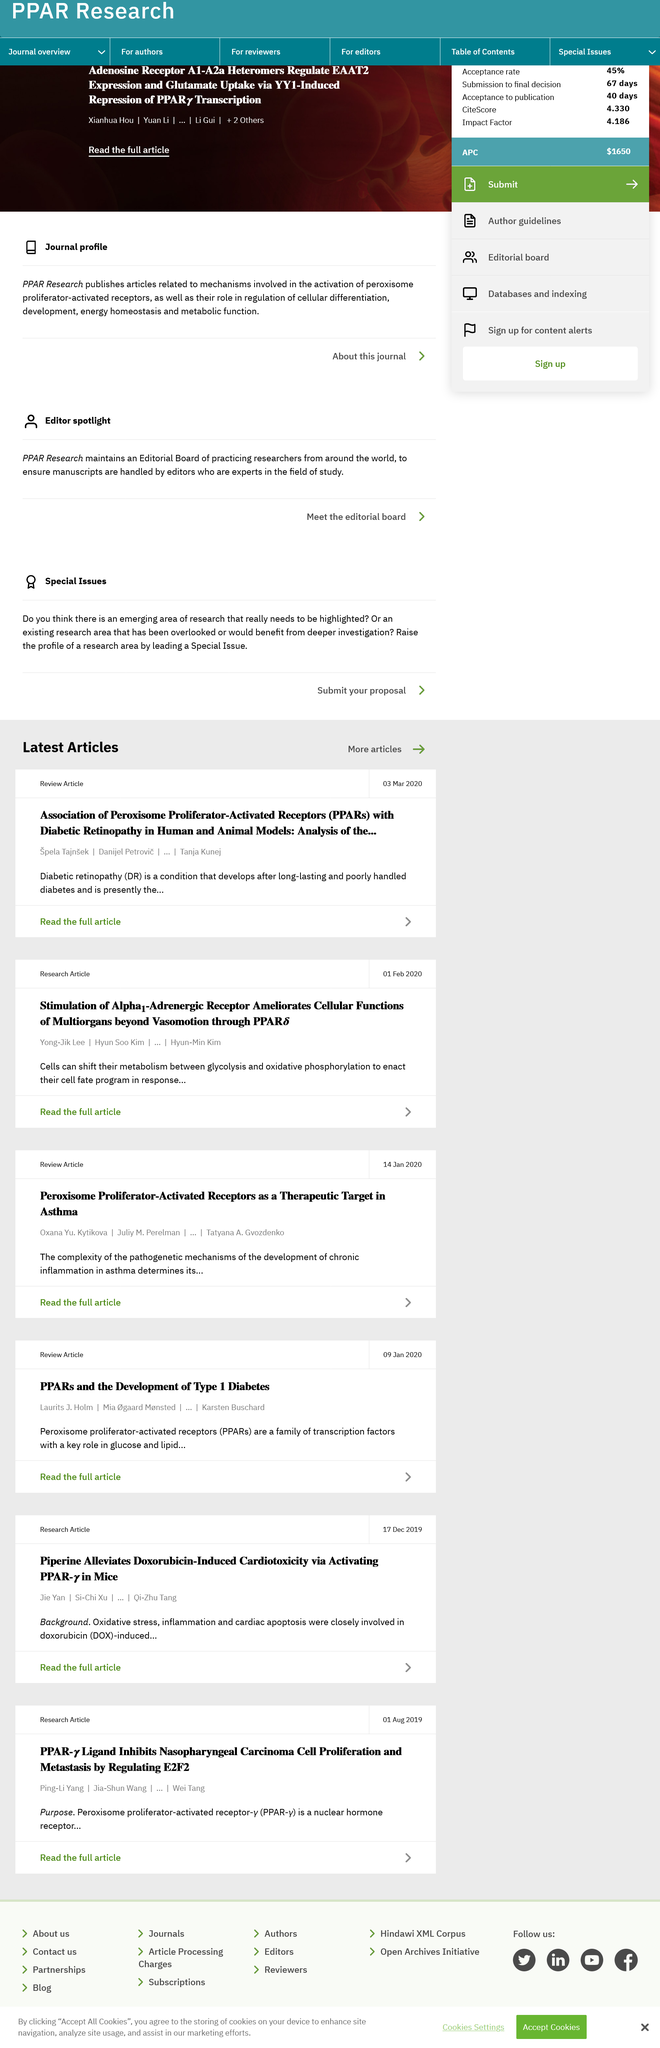Outline some significant characteristics in this image. On February 1st, 2020, the article titled "Stimulation of Alpha1-Adrenergic Receptor Ameliorates Cellular Functions of Multiorgans beyond Vasomotion through PPAR" was published. Yong-Jik Lee was the first author of the article titled "Stimulation of Alpha1-Adrenergic Receptor Ameliorates Cellular Functions of Multiorgans beyond Vasomotion through PPAR. The acronym DR in the article "Association of Peroxisome Proliferator-Activated Receptors (PPARs) with Diabetic Retinopathy in Human and Animal Models: Analysis of the...'" refers to "Diabetic Retinopathy. 